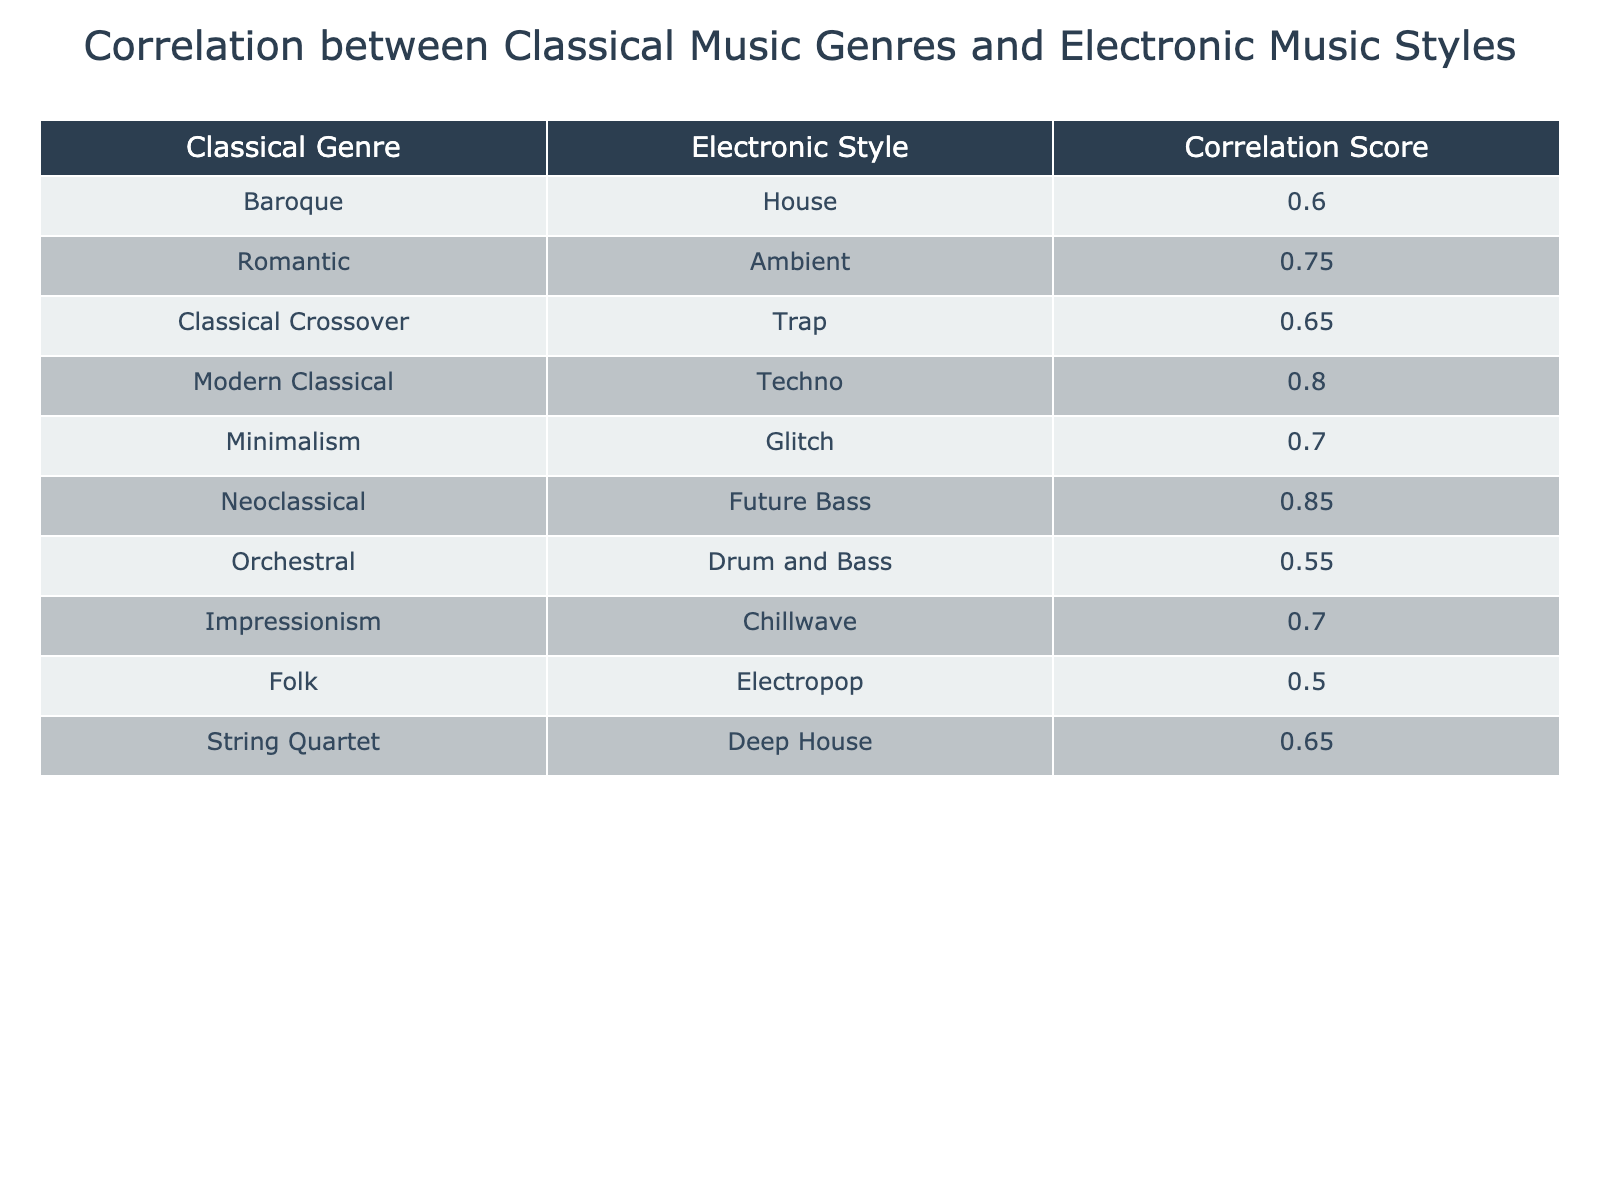What is the correlation score between Neoclassical and Future Bass? The table indicates that the correlation score between Neoclassical and Future Bass is noted in the corresponding row. By locating the row with Neoclassical, the score of 0.85 can be read directly.
Answer: 0.85 Which pair has the highest correlation score? By reviewing the correlation scores listed in the table, the pair with the highest correlation score can be identified. Neoclassical and Future Bass has the highest score of 0.85, making it the top pair.
Answer: Neoclassical and Future Bass Is the correlation score for Drum and Bass greater than the average score of all the pairs? First, the correlation score for Drum and Bass is 0.55. Next, the average of all correlation scores can be calculated: (0.60 + 0.75 + 0.65 + 0.80 + 0.70 + 0.85 + 0.55 + 0.70 + 0.50 + 0.65) / 10 = 0.675. Since 0.55 is less than 0.675, the answer is no.
Answer: No What is the overall average correlation score for all pairs? To calculate the overall average, sum all the correlation scores: 0.60 + 0.75 + 0.65 + 0.80 + 0.70 + 0.85 + 0.55 + 0.70 + 0.50 + 0.65 = 7.85. We have 10 values, so dividing by 10 gives 7.85 / 10 = 0.785.
Answer: 0.785 Which electronic style is associated with the Folk classical genre? By examining the Folk row in the table, the corresponding electronic style can be identified. The electronic style linked to the Folk genre is Electropop, as indicated in that specific row.
Answer: Electropop 